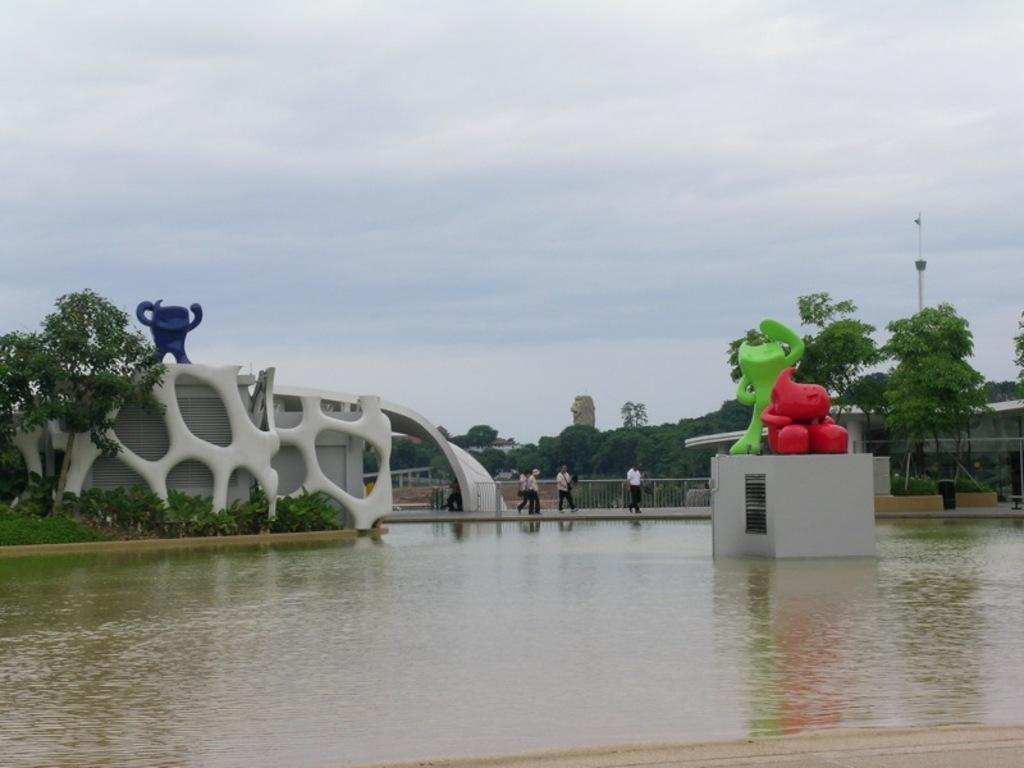What type of structures can be seen in the image? There are statues, buildings, and fences visible in the image. What natural elements are present in the image? There is water, trees, and the sky with clouds visible in the image. What man-made object can be seen in the image? There is a pole in the image. What activity is taking place in the image? There is a group of people walking on a path in the image. How many ants are crawling on the statues in the image? There are no ants present in the image; it features statues, water, trees, fences, buildings, a pole, a group of people walking on a path, and the sky with clouds. What type of bulb is used to light up the buildings in the image? There is no information about the type of bulb used to light up the buildings in the image. 